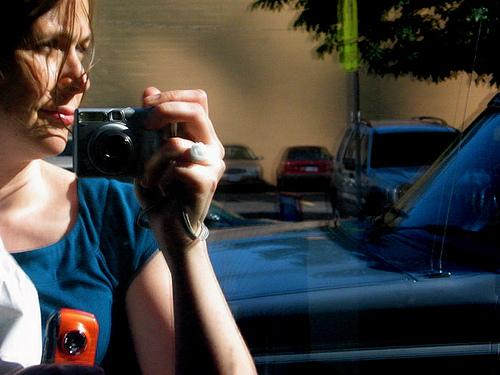What can be done using the orange thing? Please explain your reasoning. take pictures. It has a lens on it.  you can use it to take a picture. 